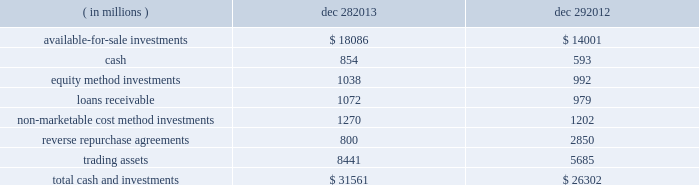The fair value of our grants receivable is determined using a discounted cash flow model , which discounts future cash flows using an appropriate yield curve .
As of december 28 , 2013 , and december 29 , 2012 , the carrying amount of our grants receivable was classified within other current assets and other long-term assets , as applicable .
Our long-term debt recognized at amortized cost is comprised of our senior notes and our convertible debentures .
The fair value of our senior notes is determined using active market prices , and it is therefore classified as level 1 .
The fair value of our convertible long-term debt is determined using discounted cash flow models with observable market inputs , and it takes into consideration variables such as interest rate changes , comparable securities , subordination discount , and credit-rating changes , and it is therefore classified as level 2 .
The nvidia corporation ( nvidia ) cross-license agreement liability in the preceding table was incurred as a result of entering into a long-term patent cross-license agreement with nvidia in january 2011 .
We agreed to make payments to nvidia over six years .
As of december 28 , 2013 , and december 29 , 2012 , the carrying amount of the liability arising from the agreement was classified within other accrued liabilities and other long-term liabilities , as applicable .
The fair value is determined using a discounted cash flow model , which discounts future cash flows using our incremental borrowing rates .
Note 5 : cash and investments cash and investments at the end of each period were as follows : ( in millions ) dec 28 , dec 29 .
In the third quarter of 2013 , we sold our shares in clearwire corporation , which had been accounted for as available-for-sale marketable equity securities , and our interest in clearwire communications , llc ( clearwire llc ) , which had been accounted for as an equity method investment .
In total , we received proceeds of $ 470 million on these transactions and recognized a gain of $ 439 million , which is included in gains ( losses ) on equity investments , net on the consolidated statements of income .
Proceeds received and gains recognized for each investment are included in the "available-for-sale investments" and "equity method investments" sections that follow .
Table of contents intel corporation notes to consolidated financial statements ( continued ) .
What percentage of total cash and investments as of dec . 29 2012 was comprised of available-for-sale investments? 
Computations: (14001 / 26302)
Answer: 0.53232. The fair value of our grants receivable is determined using a discounted cash flow model , which discounts future cash flows using an appropriate yield curve .
As of december 28 , 2013 , and december 29 , 2012 , the carrying amount of our grants receivable was classified within other current assets and other long-term assets , as applicable .
Our long-term debt recognized at amortized cost is comprised of our senior notes and our convertible debentures .
The fair value of our senior notes is determined using active market prices , and it is therefore classified as level 1 .
The fair value of our convertible long-term debt is determined using discounted cash flow models with observable market inputs , and it takes into consideration variables such as interest rate changes , comparable securities , subordination discount , and credit-rating changes , and it is therefore classified as level 2 .
The nvidia corporation ( nvidia ) cross-license agreement liability in the preceding table was incurred as a result of entering into a long-term patent cross-license agreement with nvidia in january 2011 .
We agreed to make payments to nvidia over six years .
As of december 28 , 2013 , and december 29 , 2012 , the carrying amount of the liability arising from the agreement was classified within other accrued liabilities and other long-term liabilities , as applicable .
The fair value is determined using a discounted cash flow model , which discounts future cash flows using our incremental borrowing rates .
Note 5 : cash and investments cash and investments at the end of each period were as follows : ( in millions ) dec 28 , dec 29 .
In the third quarter of 2013 , we sold our shares in clearwire corporation , which had been accounted for as available-for-sale marketable equity securities , and our interest in clearwire communications , llc ( clearwire llc ) , which had been accounted for as an equity method investment .
In total , we received proceeds of $ 470 million on these transactions and recognized a gain of $ 439 million , which is included in gains ( losses ) on equity investments , net on the consolidated statements of income .
Proceeds received and gains recognized for each investment are included in the "available-for-sale investments" and "equity method investments" sections that follow .
Table of contents intel corporation notes to consolidated financial statements ( continued ) .
As part of the proceeds from the clear wire transactions what was the percent of the gain recognized included in the equity investments , net on the consolidated statements of income .? 
Computations: (439 / 470)
Answer: 0.93404. The fair value of our grants receivable is determined using a discounted cash flow model , which discounts future cash flows using an appropriate yield curve .
As of december 28 , 2013 , and december 29 , 2012 , the carrying amount of our grants receivable was classified within other current assets and other long-term assets , as applicable .
Our long-term debt recognized at amortized cost is comprised of our senior notes and our convertible debentures .
The fair value of our senior notes is determined using active market prices , and it is therefore classified as level 1 .
The fair value of our convertible long-term debt is determined using discounted cash flow models with observable market inputs , and it takes into consideration variables such as interest rate changes , comparable securities , subordination discount , and credit-rating changes , and it is therefore classified as level 2 .
The nvidia corporation ( nvidia ) cross-license agreement liability in the preceding table was incurred as a result of entering into a long-term patent cross-license agreement with nvidia in january 2011 .
We agreed to make payments to nvidia over six years .
As of december 28 , 2013 , and december 29 , 2012 , the carrying amount of the liability arising from the agreement was classified within other accrued liabilities and other long-term liabilities , as applicable .
The fair value is determined using a discounted cash flow model , which discounts future cash flows using our incremental borrowing rates .
Note 5 : cash and investments cash and investments at the end of each period were as follows : ( in millions ) dec 28 , dec 29 .
In the third quarter of 2013 , we sold our shares in clearwire corporation , which had been accounted for as available-for-sale marketable equity securities , and our interest in clearwire communications , llc ( clearwire llc ) , which had been accounted for as an equity method investment .
In total , we received proceeds of $ 470 million on these transactions and recognized a gain of $ 439 million , which is included in gains ( losses ) on equity investments , net on the consolidated statements of income .
Proceeds received and gains recognized for each investment are included in the "available-for-sale investments" and "equity method investments" sections that follow .
Table of contents intel corporation notes to consolidated financial statements ( continued ) .
What was the percent of the increase in the total cash and investments from 2012 to 2013? 
Rationale: the total cash and investments increased by 19.9% from 2012 to 2013
Computations: ((31561 - 26302) / 26302)
Answer: 0.19995. 